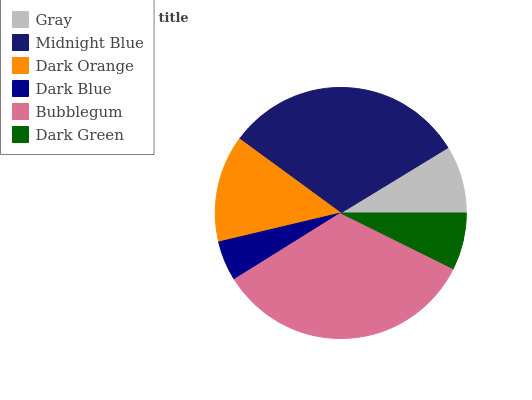Is Dark Blue the minimum?
Answer yes or no. Yes. Is Bubblegum the maximum?
Answer yes or no. Yes. Is Midnight Blue the minimum?
Answer yes or no. No. Is Midnight Blue the maximum?
Answer yes or no. No. Is Midnight Blue greater than Gray?
Answer yes or no. Yes. Is Gray less than Midnight Blue?
Answer yes or no. Yes. Is Gray greater than Midnight Blue?
Answer yes or no. No. Is Midnight Blue less than Gray?
Answer yes or no. No. Is Dark Orange the high median?
Answer yes or no. Yes. Is Gray the low median?
Answer yes or no. Yes. Is Gray the high median?
Answer yes or no. No. Is Dark Green the low median?
Answer yes or no. No. 